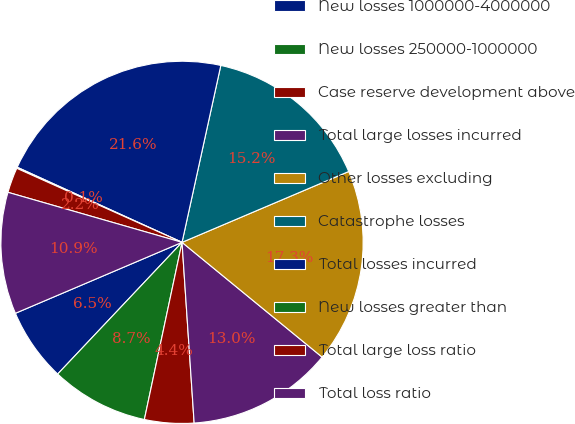Convert chart to OTSL. <chart><loc_0><loc_0><loc_500><loc_500><pie_chart><fcel>New losses 1000000-4000000<fcel>New losses 250000-1000000<fcel>Case reserve development above<fcel>Total large losses incurred<fcel>Other losses excluding<fcel>Catastrophe losses<fcel>Total losses incurred<fcel>New losses greater than<fcel>Total large loss ratio<fcel>Total loss ratio<nl><fcel>6.55%<fcel>8.71%<fcel>4.4%<fcel>13.01%<fcel>17.32%<fcel>15.17%<fcel>21.63%<fcel>0.1%<fcel>2.25%<fcel>10.86%<nl></chart> 